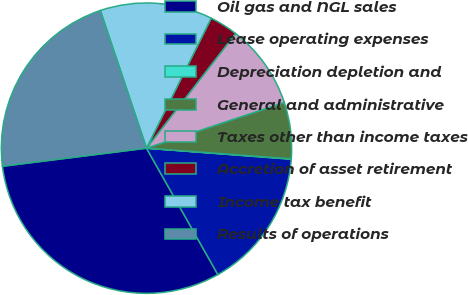Convert chart. <chart><loc_0><loc_0><loc_500><loc_500><pie_chart><fcel>Oil gas and NGL sales<fcel>Lease operating expenses<fcel>Depreciation depletion and<fcel>General and administrative<fcel>Taxes other than income taxes<fcel>Accretion of asset retirement<fcel>Income tax benefit<fcel>Results of operations<nl><fcel>31.19%<fcel>15.61%<fcel>0.04%<fcel>6.27%<fcel>9.39%<fcel>3.16%<fcel>12.5%<fcel>21.84%<nl></chart> 